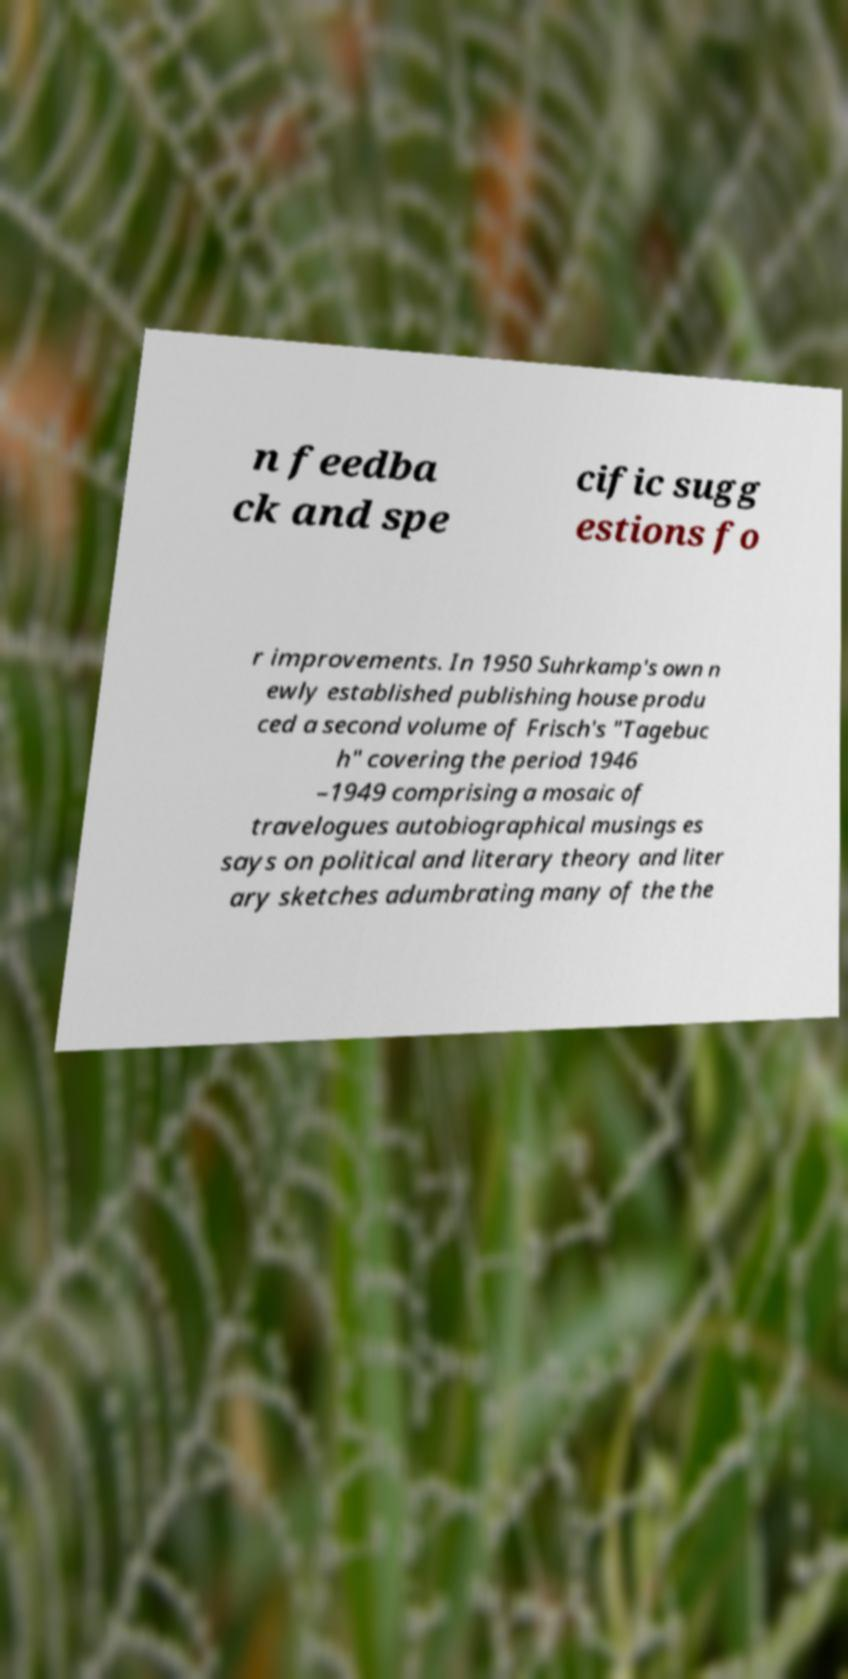For documentation purposes, I need the text within this image transcribed. Could you provide that? n feedba ck and spe cific sugg estions fo r improvements. In 1950 Suhrkamp's own n ewly established publishing house produ ced a second volume of Frisch's "Tagebuc h" covering the period 1946 –1949 comprising a mosaic of travelogues autobiographical musings es says on political and literary theory and liter ary sketches adumbrating many of the the 